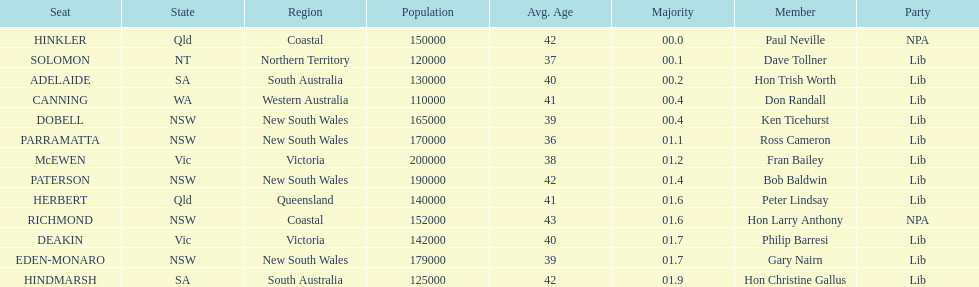What is the overall count of seats? 13. 